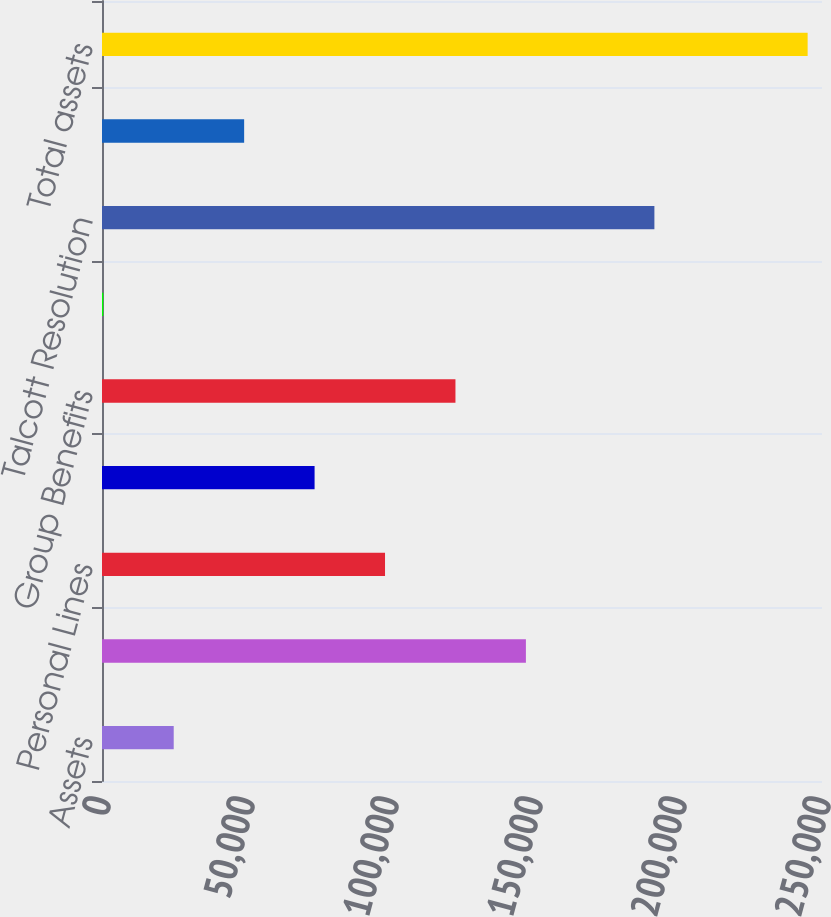<chart> <loc_0><loc_0><loc_500><loc_500><bar_chart><fcel>Assets<fcel>Commercial Lines<fcel>Personal Lines<fcel>Property & Casualty Other<fcel>Group Benefits<fcel>Mutual Funds<fcel>Talcott Resolution<fcel>Corporate 1<fcel>Total assets<nl><fcel>24900<fcel>147185<fcel>98271<fcel>73814<fcel>122728<fcel>443<fcel>191801<fcel>49357<fcel>245013<nl></chart> 